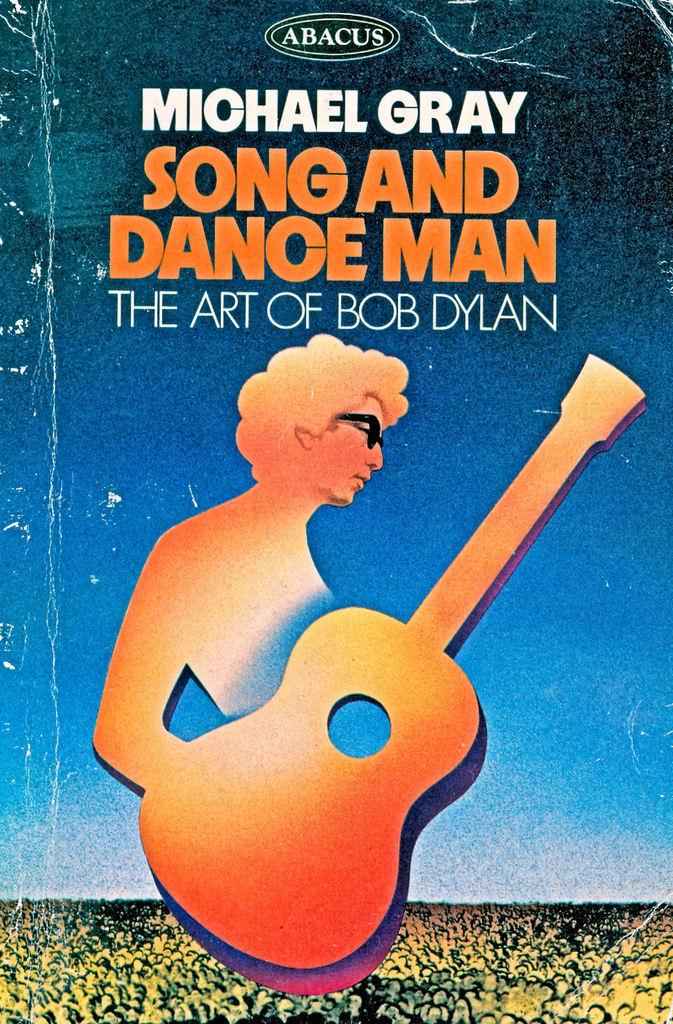<image>
Render a clear and concise summary of the photo. Cover showing a man playing the guitar and the name "Michael Gray". 